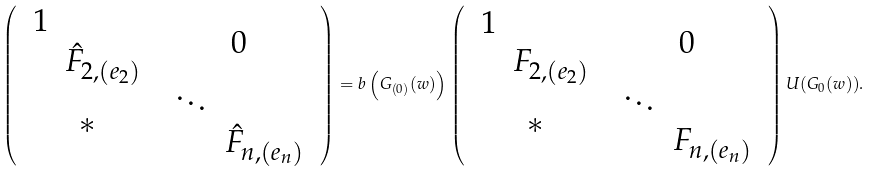<formula> <loc_0><loc_0><loc_500><loc_500>\left ( \begin{array} { c c } \begin{array} { l l } 1 & \\ & \hat { F } _ { 2 , ( e _ { 2 } ) } \end{array} & 0 \\ \ast & \begin{array} { l l } \ddots & \\ & \hat { F } _ { n , ( e _ { n } ) } \end{array} \end{array} \right ) = b \left ( G _ { ( 0 ) } ( w ) \right ) \left ( \begin{array} { c c } \begin{array} { l l } 1 & \\ & F _ { 2 , ( e _ { 2 } ) } \end{array} & 0 \\ \ast & \begin{array} { l l } \ddots & \\ & F _ { n , ( e _ { n } ) } \end{array} \end{array} \right ) U ( G _ { 0 } ( w ) ) .</formula> 